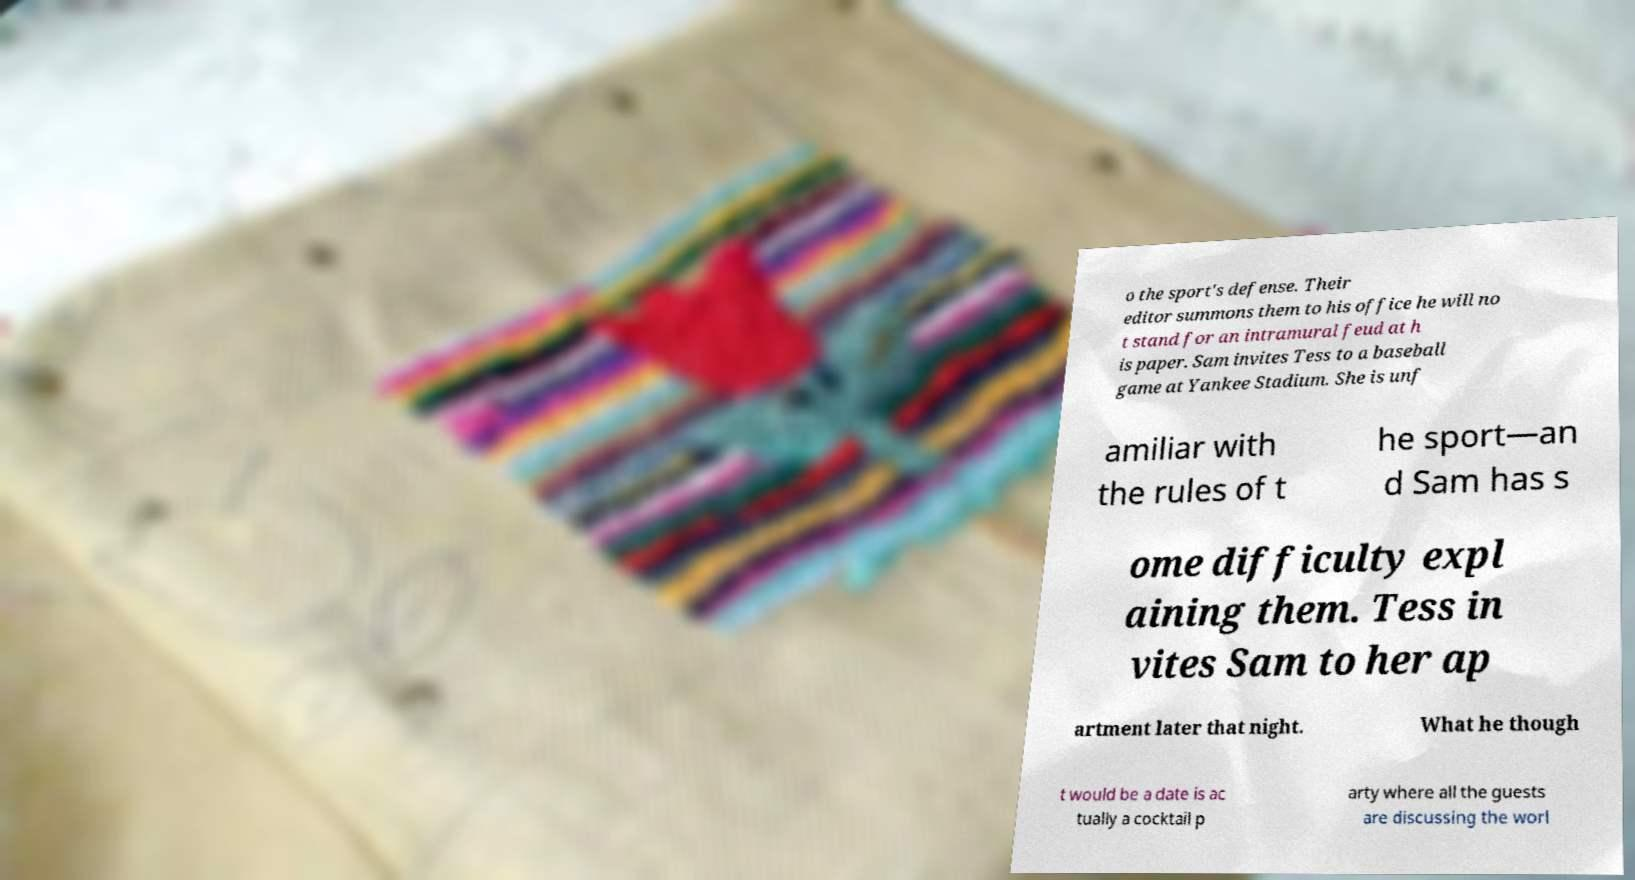Please read and relay the text visible in this image. What does it say? o the sport's defense. Their editor summons them to his office he will no t stand for an intramural feud at h is paper. Sam invites Tess to a baseball game at Yankee Stadium. She is unf amiliar with the rules of t he sport—an d Sam has s ome difficulty expl aining them. Tess in vites Sam to her ap artment later that night. What he though t would be a date is ac tually a cocktail p arty where all the guests are discussing the worl 